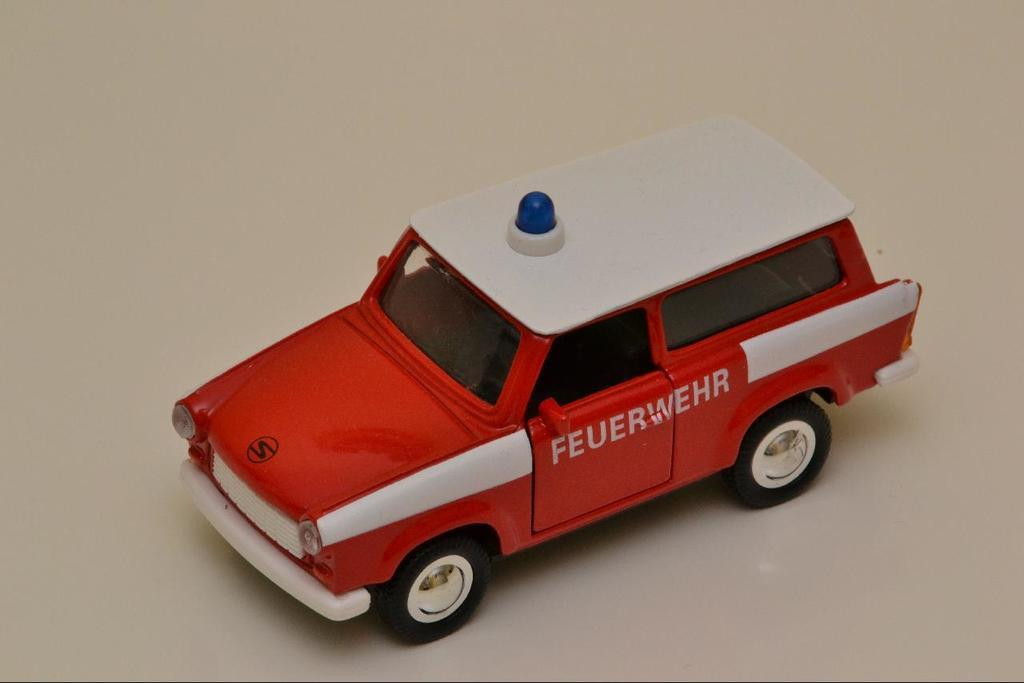What type of toy is in the image? There is a toy car in the image. What color is the toy car? The toy car is red in color. Are there any other colors on the toy car? Yes, there are blue elements on the toy car. What verse is being recited by the toy car in the image? There is no verse being recited by the toy car in the image, as it is an inanimate object and cannot speak or recite anything. 